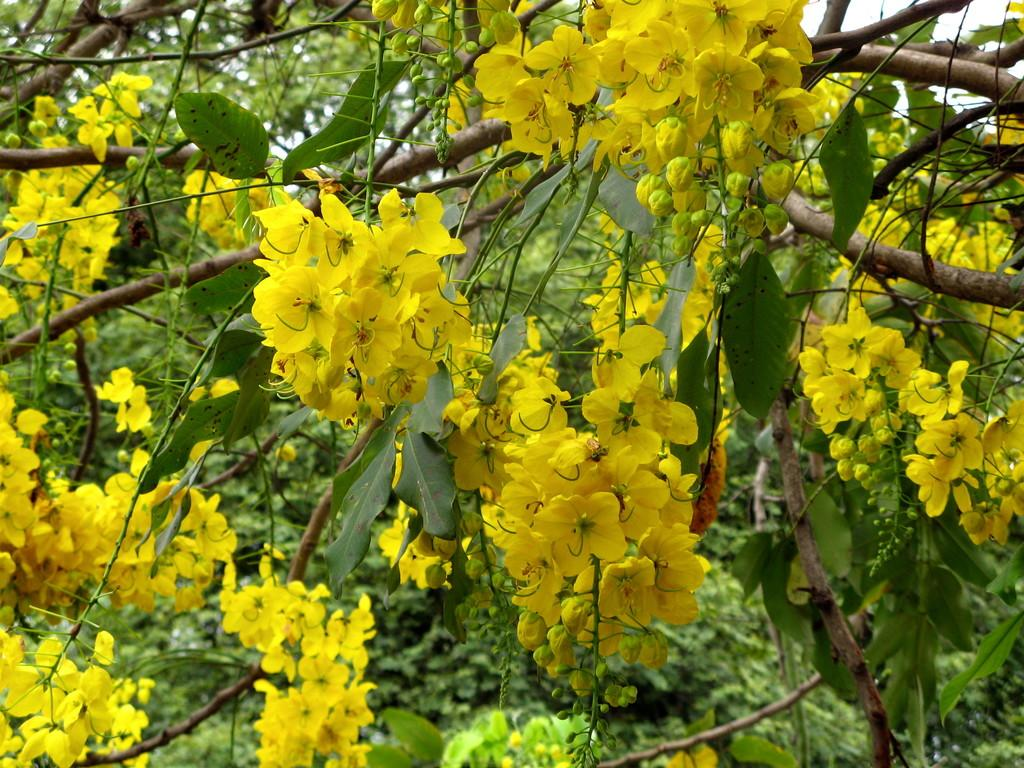What type of vegetation can be seen in the image? There are trees in the image. What additional feature can be observed on the trees? The trees have flowers. Where is the throne located in the image? There is no throne present in the image. What type of ray can be seen emanating from the flowers in the image? There is no ray emanating from the flowers in the image. 